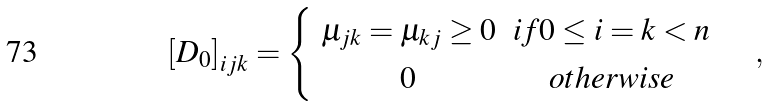<formula> <loc_0><loc_0><loc_500><loc_500>\left [ D _ { 0 } \right ] _ { i j k } = \begin{cases} \begin{array} { c c } \mu _ { j k } = \mu _ { k j } \geq 0 & i f 0 \leq i = k < n \\ 0 & o t h e r w i s e \end{array} \end{cases} ,</formula> 